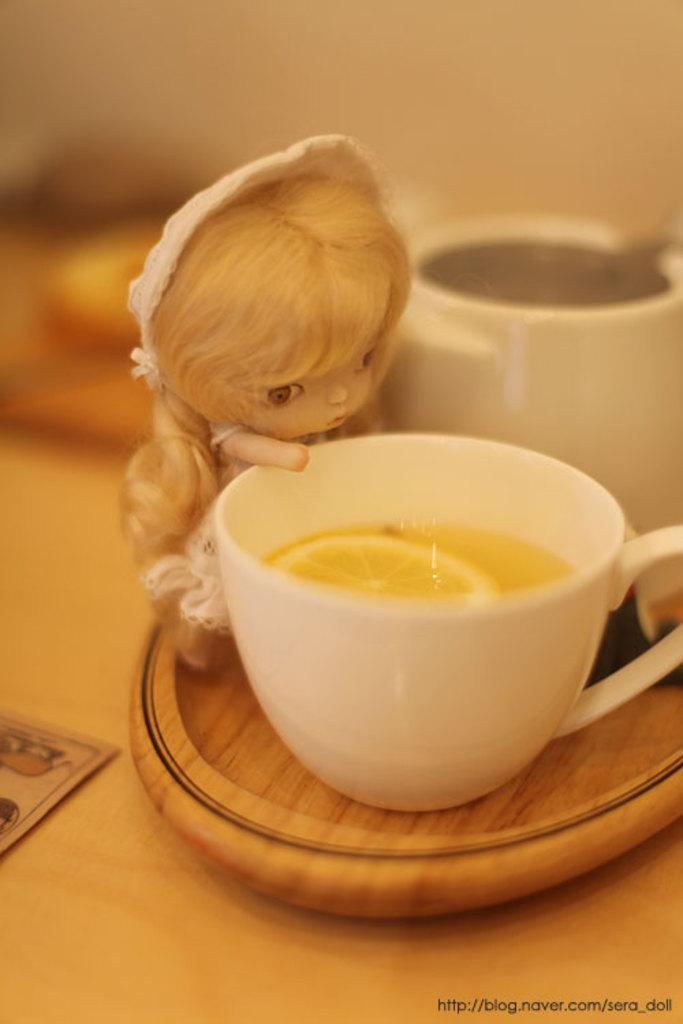What is the main subject in the center of the image? There is a doll in the center of the image. Can you describe any other objects in the image? There is a cup on a table in the image. Where is the closest bead store to the location of the image? The provided facts do not give any information about the location of the image, so it is impossible to determine the closest bead store. 